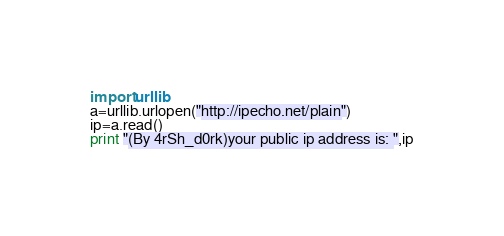Convert code to text. <code><loc_0><loc_0><loc_500><loc_500><_Python_>import urllib
a=urllib.urlopen("http://ipecho.net/plain")
ip=a.read()
print "(By 4rSh_d0rk)your public ip address is: ",ip
</code> 